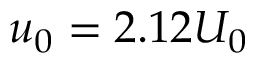<formula> <loc_0><loc_0><loc_500><loc_500>u _ { 0 } = 2 . 1 2 U _ { 0 }</formula> 